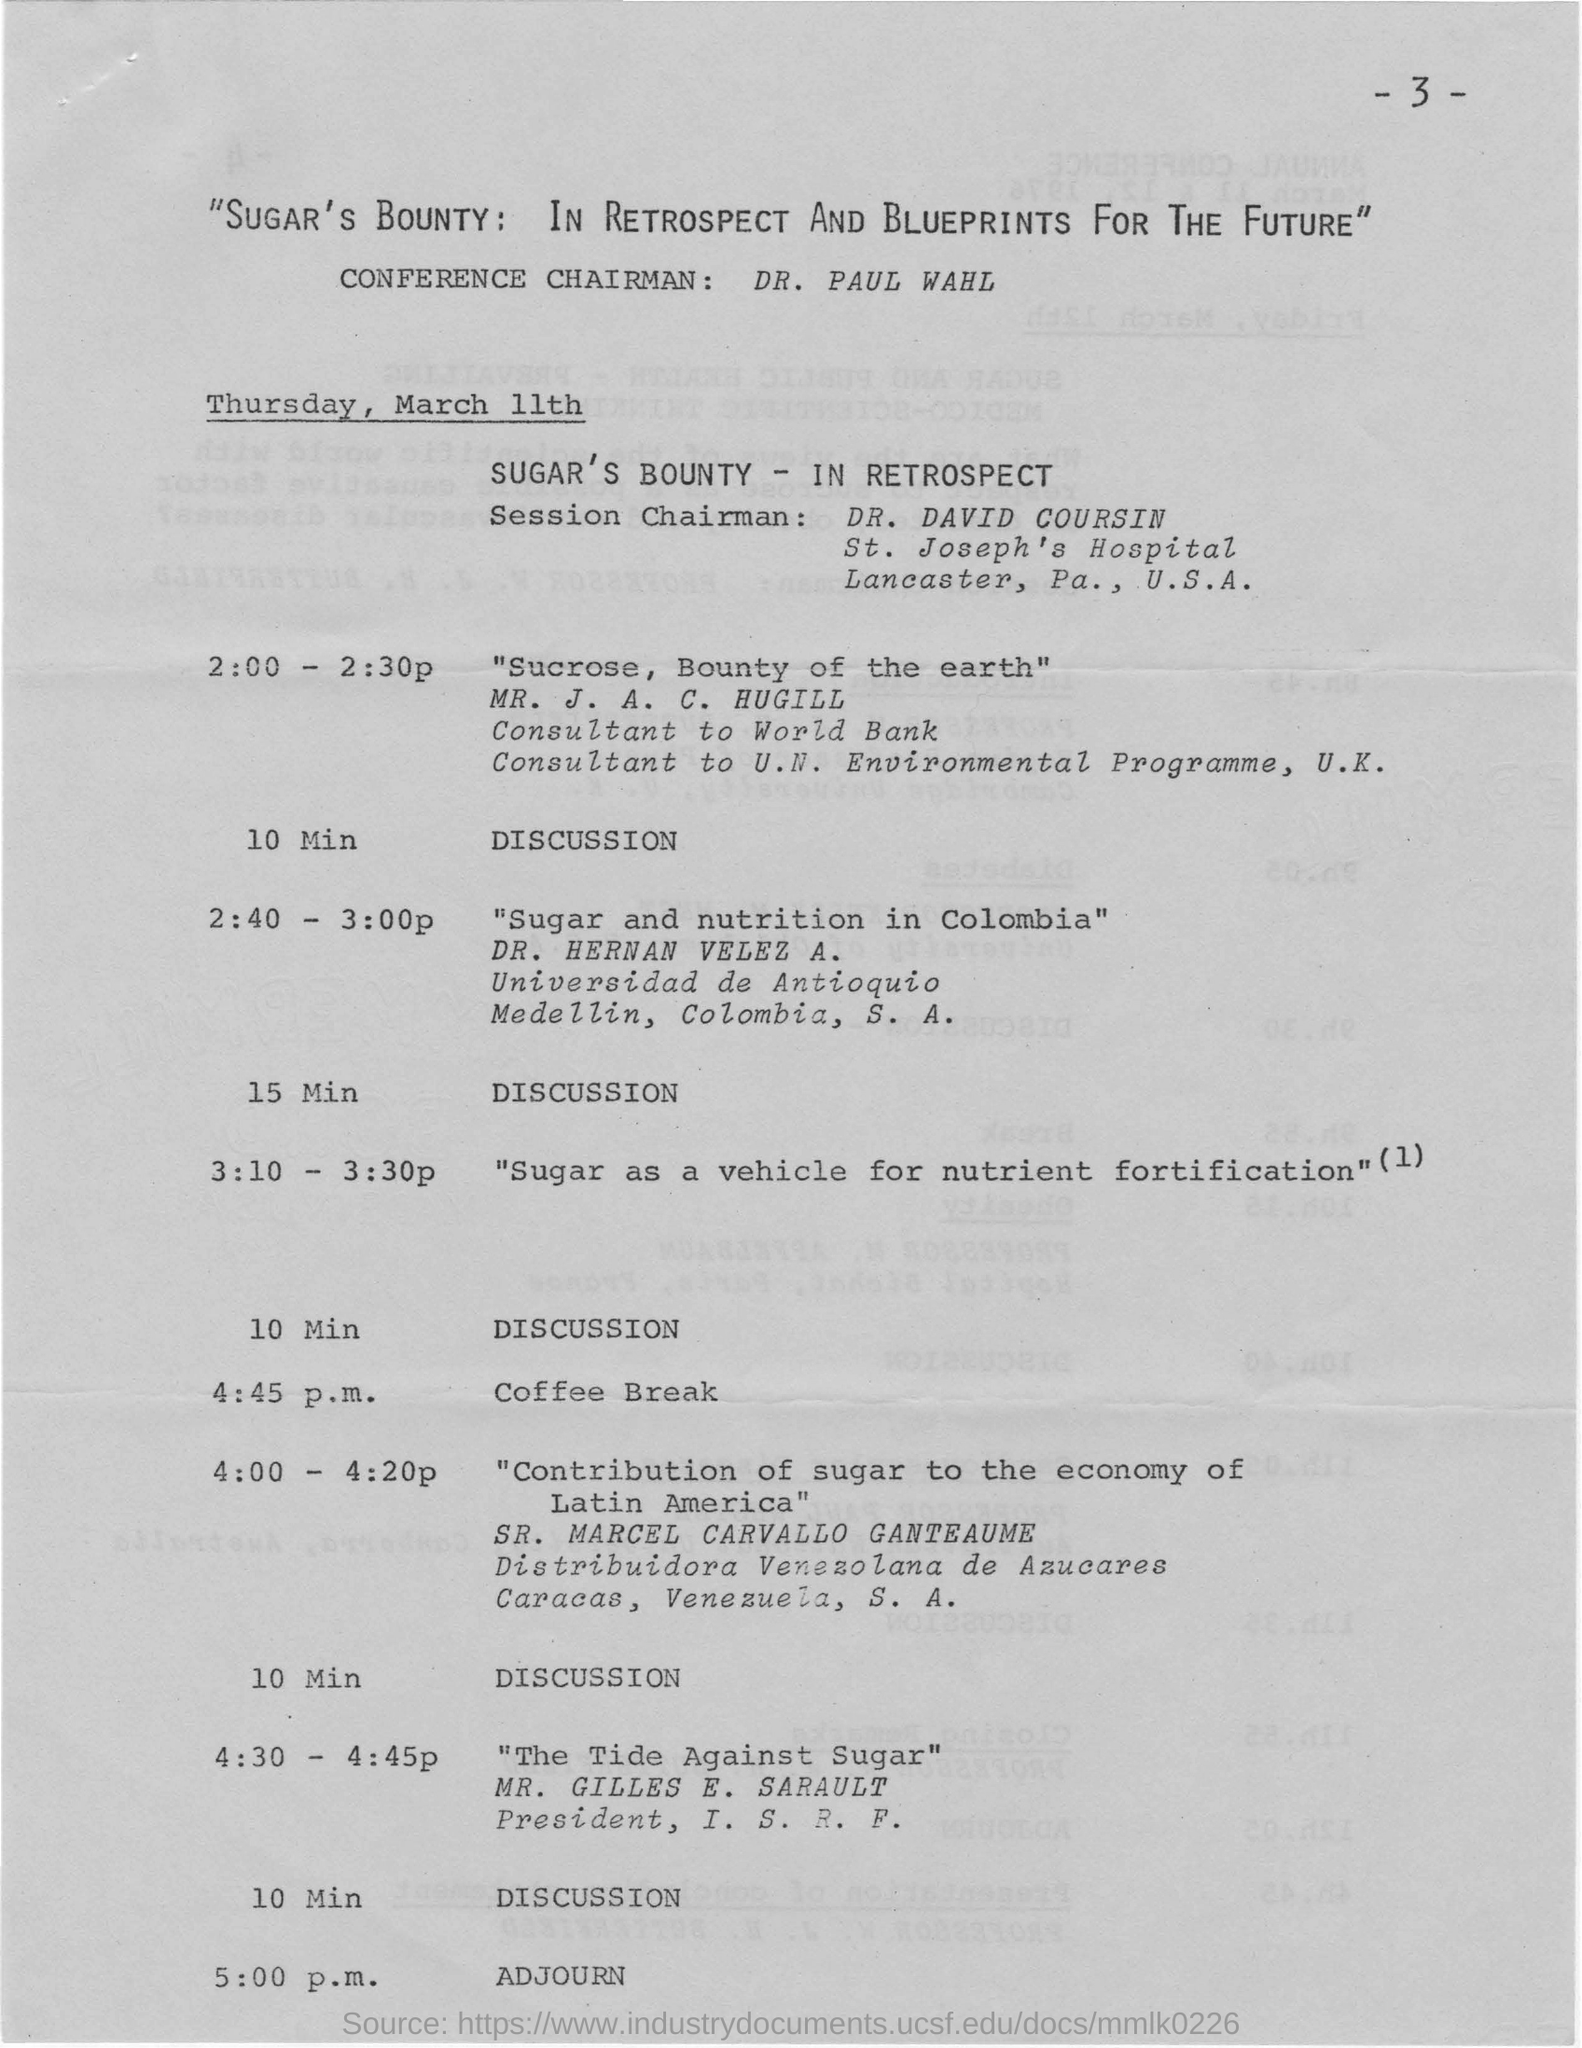Who is the conference chairman?
Make the answer very short. DR. PAUL WAHL. Which date is the conference conducted?
Give a very brief answer. THURSDAY, MARCH 11TH. Who is Dr. David Coursin?
Provide a succinct answer. Session Chairman. At what time is the coffee break provided?
Provide a succinct answer. 4:45 P.M. Who discussed about the topic " Sugar and nutrition in Colombia" ?
Provide a succinct answer. DR. HERNAN VELEZ A. At what time, the conference was adjourned?
Give a very brief answer. 5.00  p.m. 